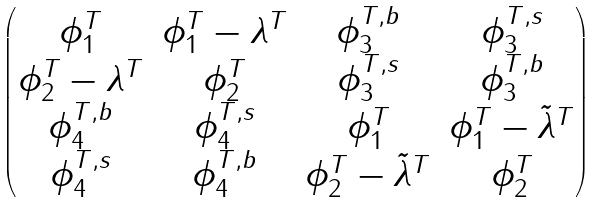Convert formula to latex. <formula><loc_0><loc_0><loc_500><loc_500>\begin{pmatrix} \phi _ { 1 } ^ { T } & \phi _ { 1 } ^ { T } - \lambda ^ { T } & \phi _ { 3 } ^ { T , b } & \phi _ { 3 } ^ { T , s } \\ \phi _ { 2 } ^ { T } - \lambda ^ { T } & \phi _ { 2 } ^ { T } & \phi _ { 3 } ^ { T , s } & \phi _ { 3 } ^ { T , b } \\ \phi _ { 4 } ^ { T , b } & \phi _ { 4 } ^ { T , s } & \phi _ { 1 } ^ { T } & \phi _ { 1 } ^ { T } - \tilde { \lambda } ^ { T } \\ \phi _ { 4 } ^ { T , s } & \phi _ { 4 } ^ { T , b } & \phi _ { 2 } ^ { T } - \tilde { \lambda } ^ { T } & \phi _ { 2 } ^ { T } \end{pmatrix}</formula> 